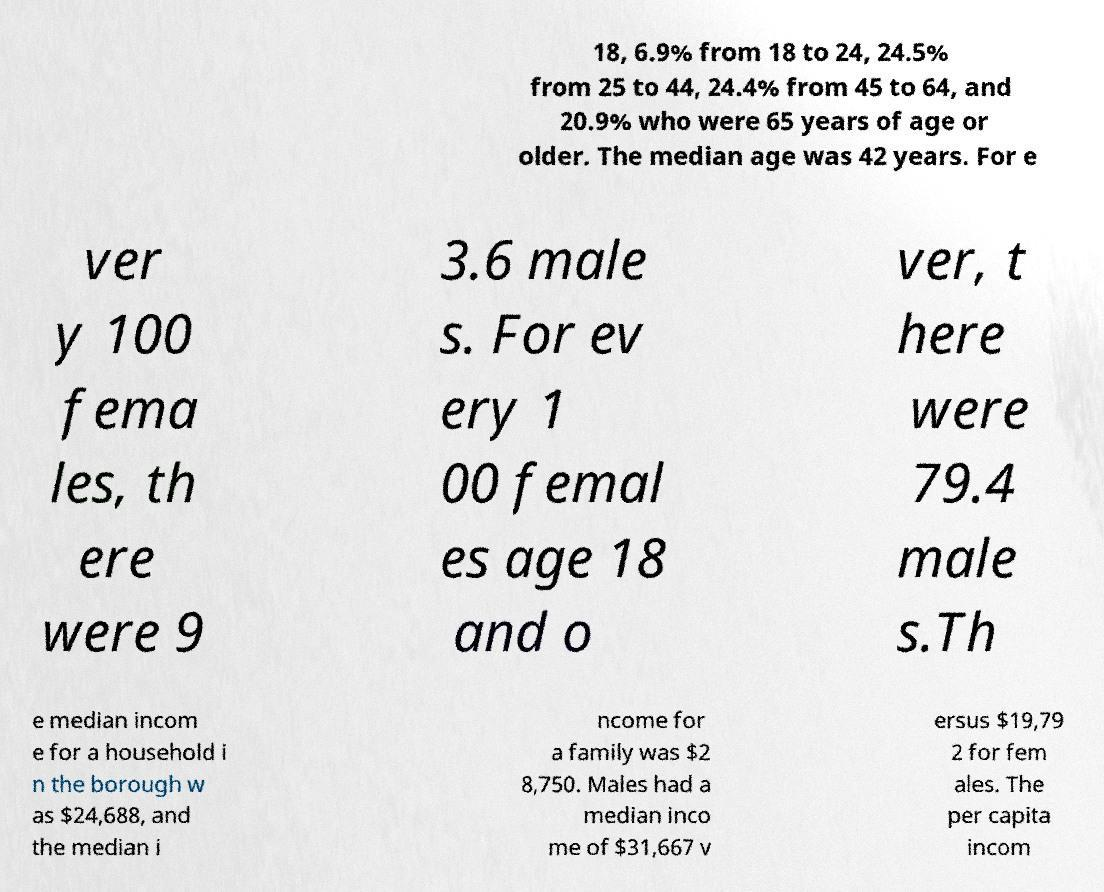Please identify and transcribe the text found in this image. 18, 6.9% from 18 to 24, 24.5% from 25 to 44, 24.4% from 45 to 64, and 20.9% who were 65 years of age or older. The median age was 42 years. For e ver y 100 fema les, th ere were 9 3.6 male s. For ev ery 1 00 femal es age 18 and o ver, t here were 79.4 male s.Th e median incom e for a household i n the borough w as $24,688, and the median i ncome for a family was $2 8,750. Males had a median inco me of $31,667 v ersus $19,79 2 for fem ales. The per capita incom 